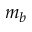<formula> <loc_0><loc_0><loc_500><loc_500>m _ { b }</formula> 